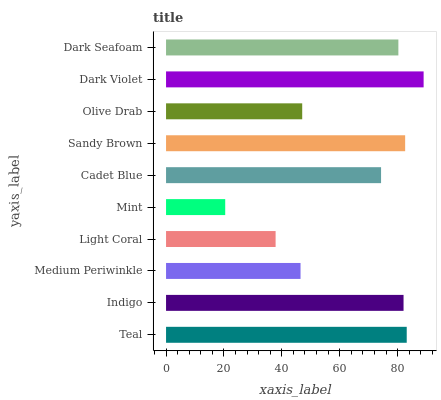Is Mint the minimum?
Answer yes or no. Yes. Is Dark Violet the maximum?
Answer yes or no. Yes. Is Indigo the minimum?
Answer yes or no. No. Is Indigo the maximum?
Answer yes or no. No. Is Teal greater than Indigo?
Answer yes or no. Yes. Is Indigo less than Teal?
Answer yes or no. Yes. Is Indigo greater than Teal?
Answer yes or no. No. Is Teal less than Indigo?
Answer yes or no. No. Is Dark Seafoam the high median?
Answer yes or no. Yes. Is Cadet Blue the low median?
Answer yes or no. Yes. Is Teal the high median?
Answer yes or no. No. Is Light Coral the low median?
Answer yes or no. No. 